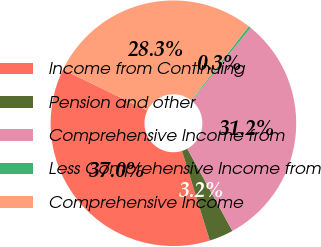<chart> <loc_0><loc_0><loc_500><loc_500><pie_chart><fcel>Income from Continuing<fcel>Pension and other<fcel>Comprehensive Income from<fcel>Less Comprehensive Income from<fcel>Comprehensive Income<nl><fcel>37.0%<fcel>3.19%<fcel>31.21%<fcel>0.3%<fcel>28.31%<nl></chart> 